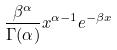Convert formula to latex. <formula><loc_0><loc_0><loc_500><loc_500>\frac { \beta ^ { \alpha } } { \Gamma ( \alpha ) } x ^ { \alpha - 1 } e ^ { - \beta x }</formula> 